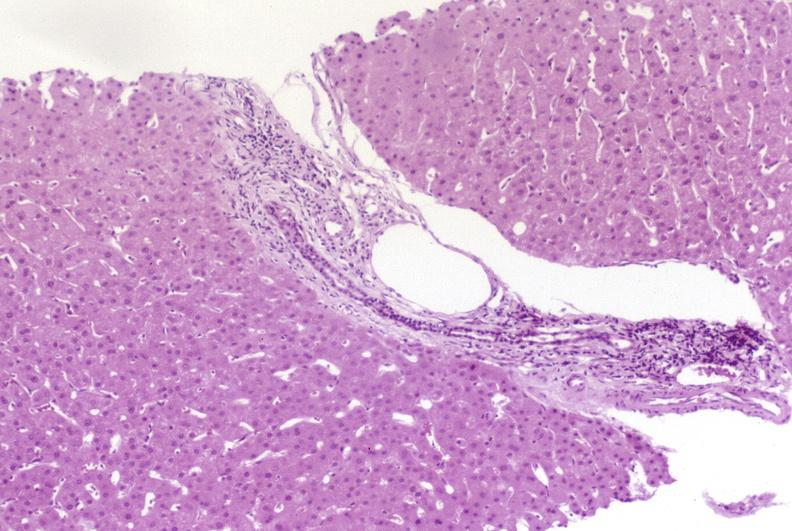what is present?
Answer the question using a single word or phrase. Liver 